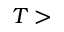<formula> <loc_0><loc_0><loc_500><loc_500>T ></formula> 